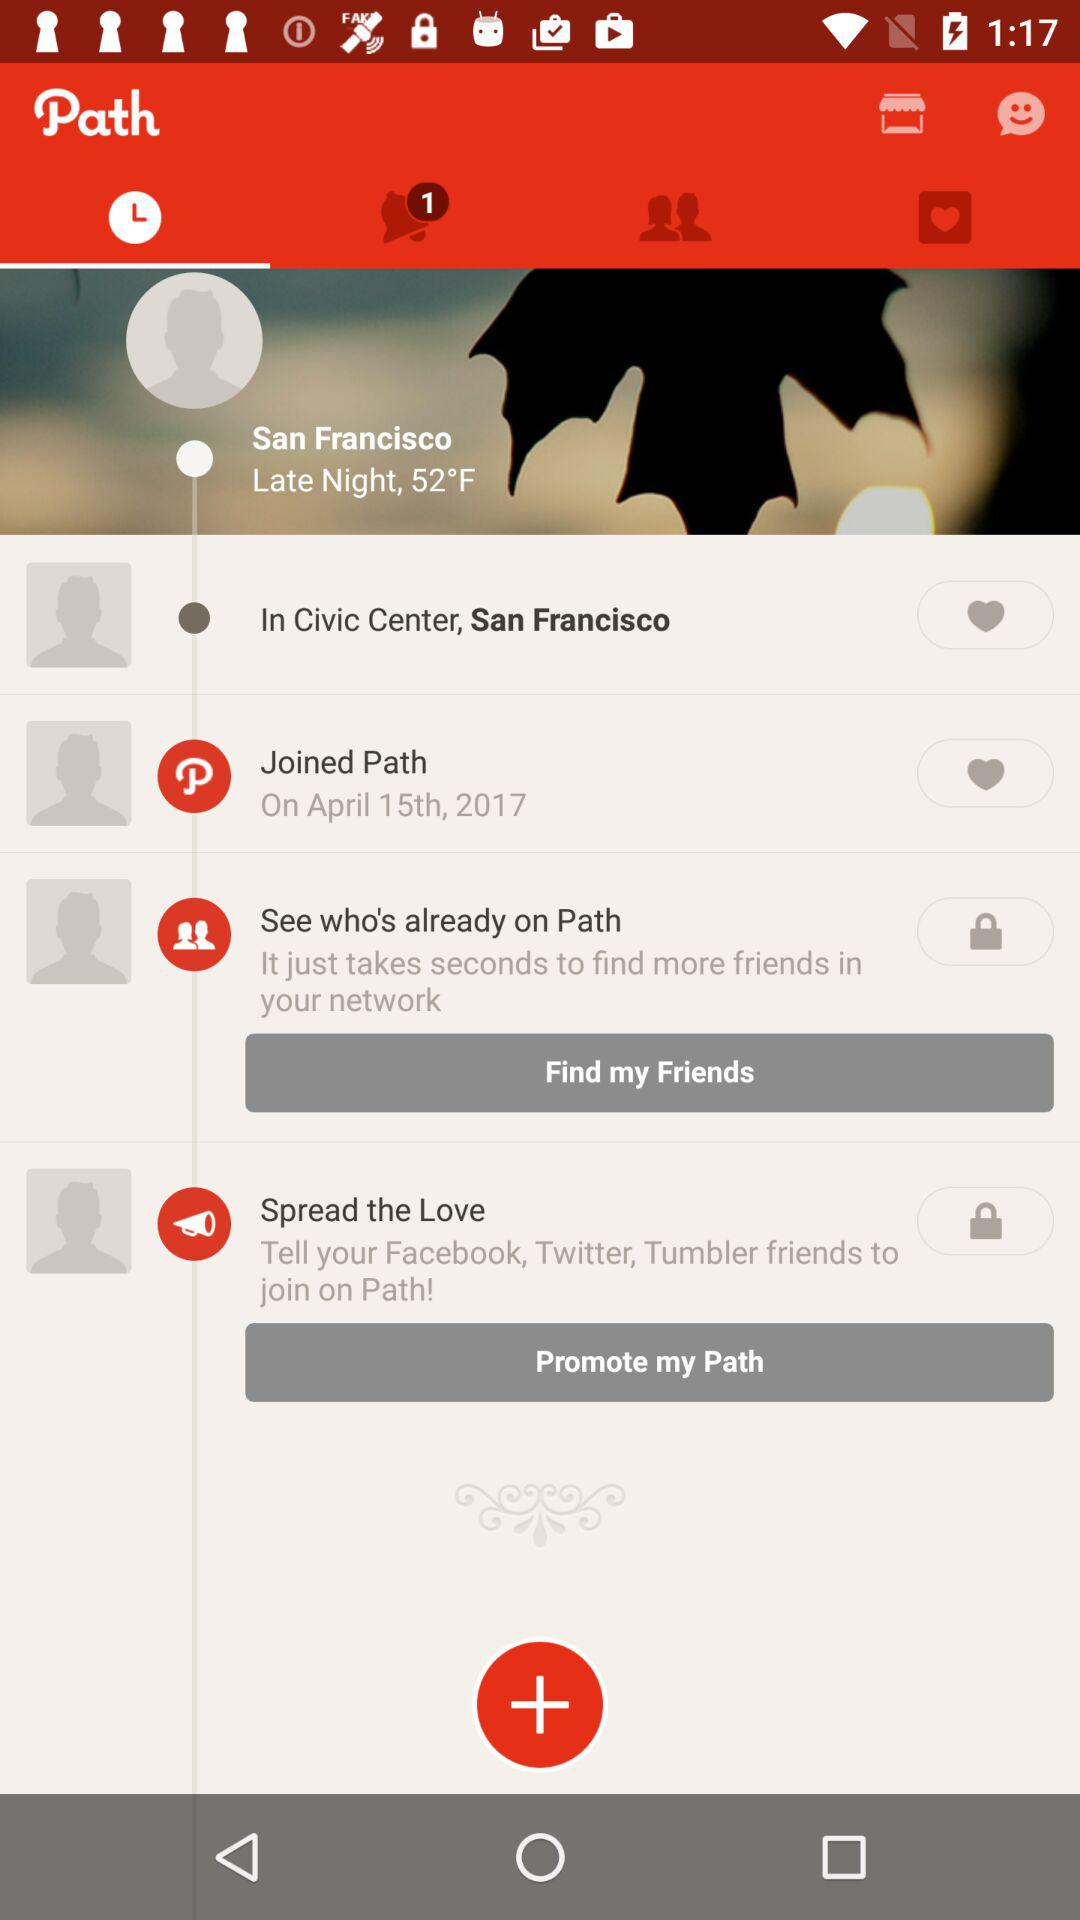What is the name of user?
When the provided information is insufficient, respond with <no answer>. <no answer> 